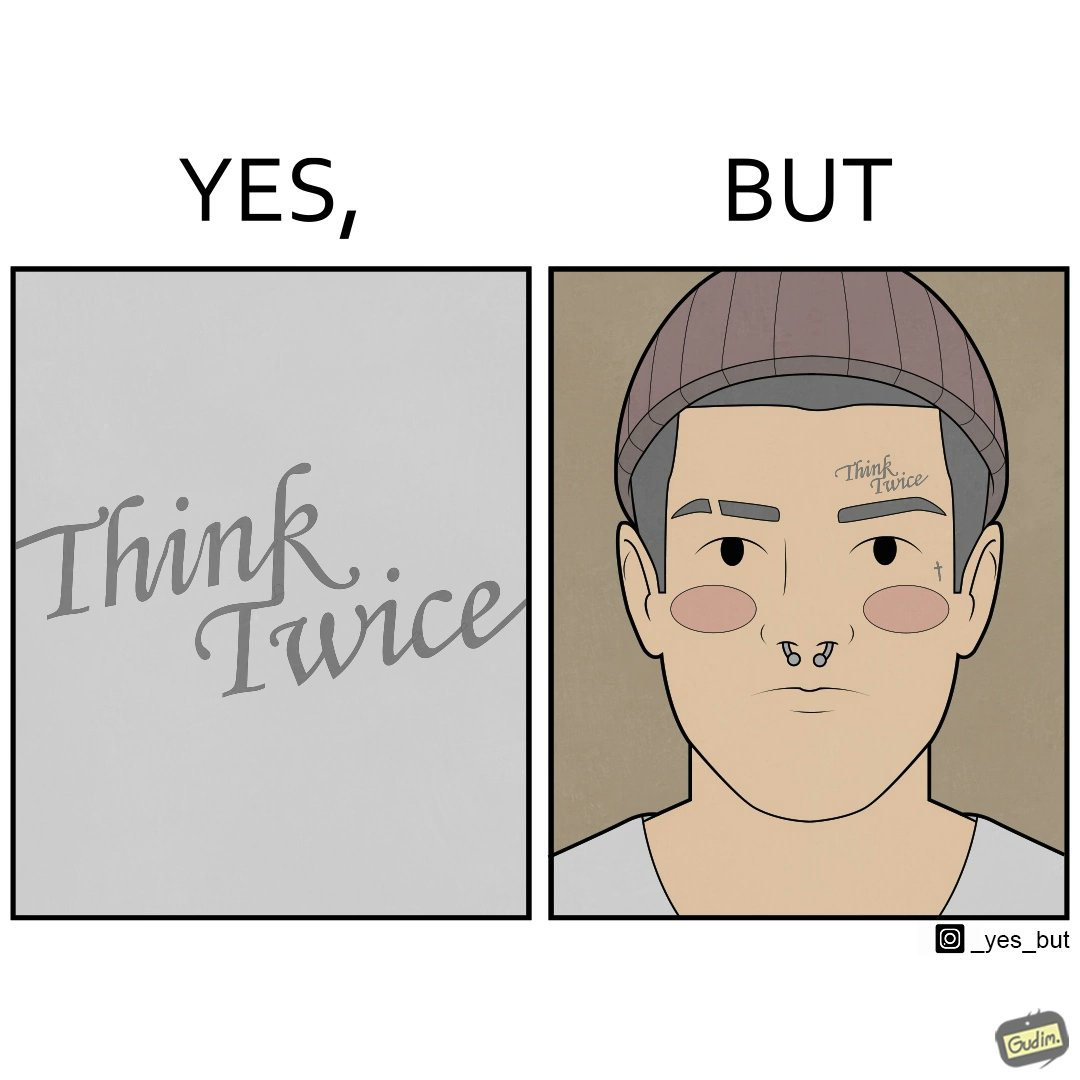Is this a satirical image? Yes, this image is satirical. 